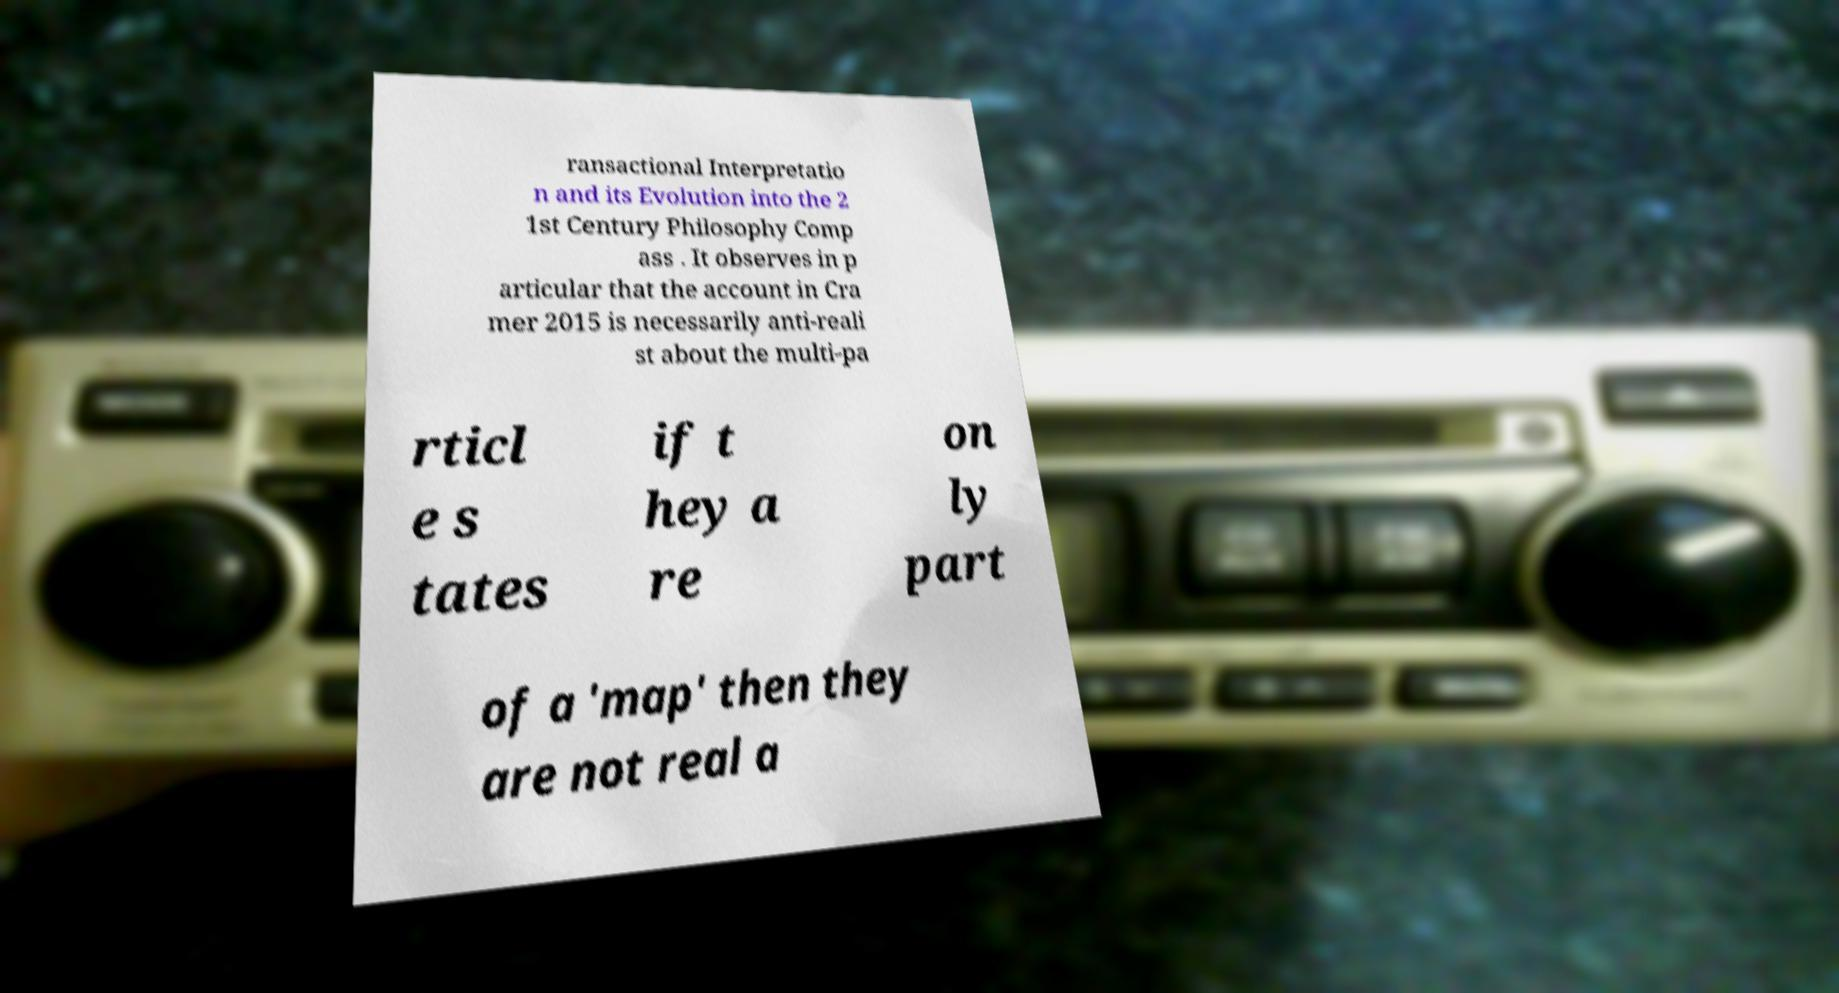I need the written content from this picture converted into text. Can you do that? ransactional Interpretatio n and its Evolution into the 2 1st Century Philosophy Comp ass . It observes in p articular that the account in Cra mer 2015 is necessarily anti-reali st about the multi-pa rticl e s tates if t hey a re on ly part of a 'map' then they are not real a 